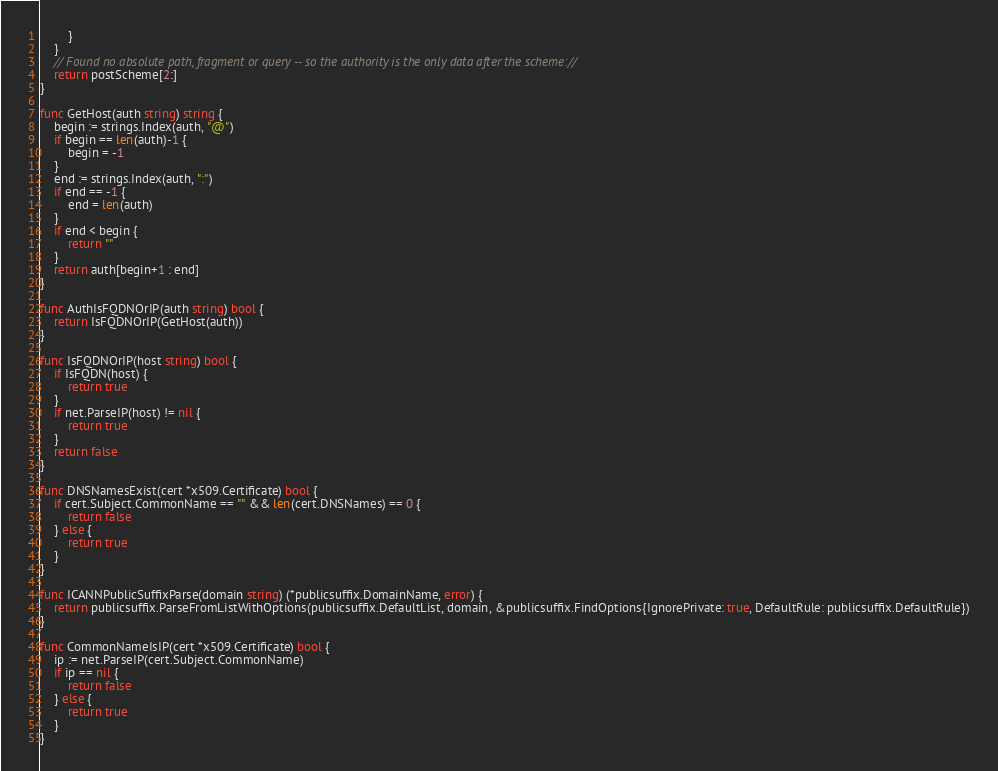<code> <loc_0><loc_0><loc_500><loc_500><_Go_>		}
	}
	// Found no absolute path, fragment or query -- so the authority is the only data after the scheme://
	return postScheme[2:]
}

func GetHost(auth string) string {
	begin := strings.Index(auth, "@")
	if begin == len(auth)-1 {
		begin = -1
	}
	end := strings.Index(auth, ":")
	if end == -1 {
		end = len(auth)
	}
	if end < begin {
		return ""
	}
	return auth[begin+1 : end]
}

func AuthIsFQDNOrIP(auth string) bool {
	return IsFQDNOrIP(GetHost(auth))
}

func IsFQDNOrIP(host string) bool {
	if IsFQDN(host) {
		return true
	}
	if net.ParseIP(host) != nil {
		return true
	}
	return false
}

func DNSNamesExist(cert *x509.Certificate) bool {
	if cert.Subject.CommonName == "" && len(cert.DNSNames) == 0 {
		return false
	} else {
		return true
	}
}

func ICANNPublicSuffixParse(domain string) (*publicsuffix.DomainName, error) {
	return publicsuffix.ParseFromListWithOptions(publicsuffix.DefaultList, domain, &publicsuffix.FindOptions{IgnorePrivate: true, DefaultRule: publicsuffix.DefaultRule})
}

func CommonNameIsIP(cert *x509.Certificate) bool {
	ip := net.ParseIP(cert.Subject.CommonName)
	if ip == nil {
		return false
	} else {
		return true
	}
}
</code> 